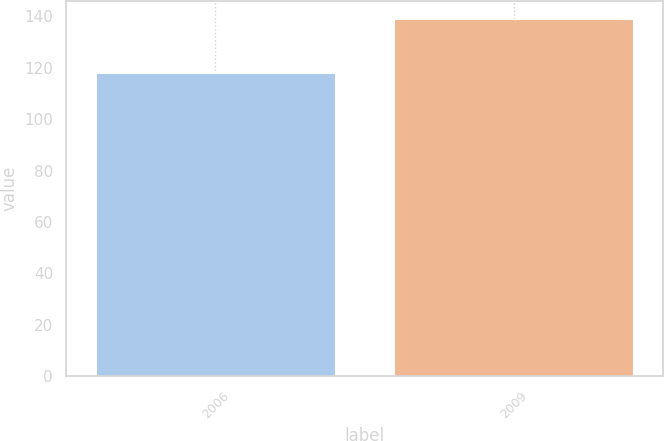Convert chart to OTSL. <chart><loc_0><loc_0><loc_500><loc_500><bar_chart><fcel>2006<fcel>2009<nl><fcel>118<fcel>139<nl></chart> 